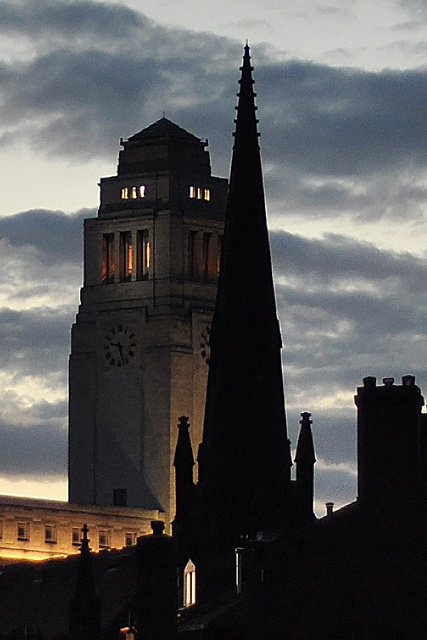Describe the objects in this image and their specific colors. I can see clock in black and darkgray tones and clock in darkgray, black, and gray tones in this image. 